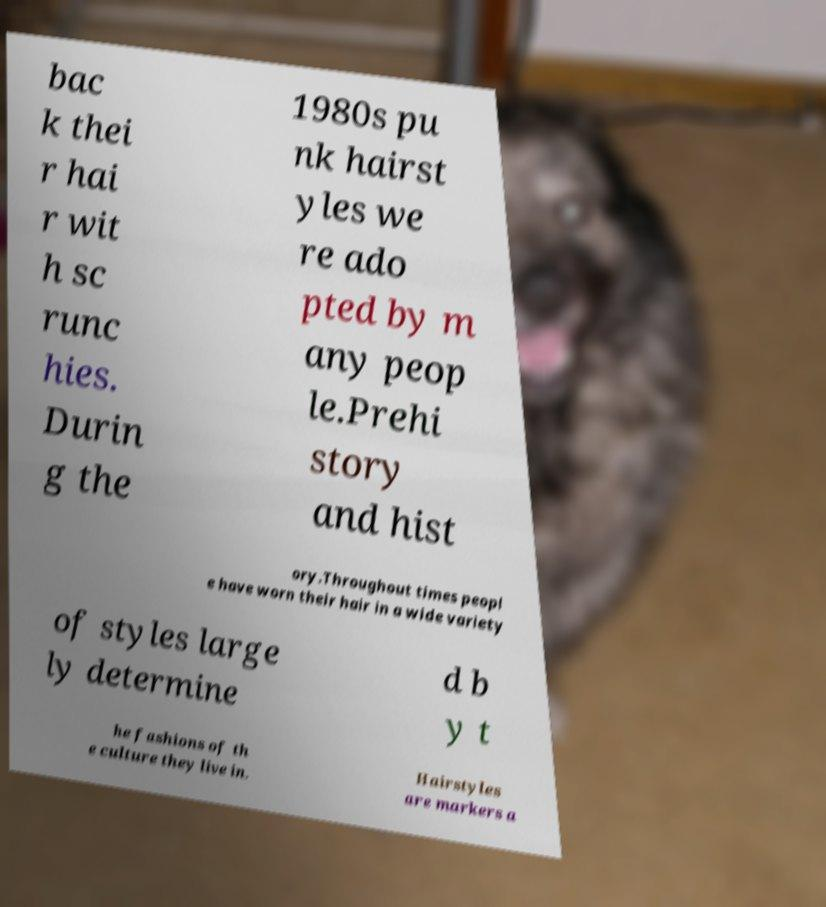I need the written content from this picture converted into text. Can you do that? bac k thei r hai r wit h sc runc hies. Durin g the 1980s pu nk hairst yles we re ado pted by m any peop le.Prehi story and hist ory.Throughout times peopl e have worn their hair in a wide variety of styles large ly determine d b y t he fashions of th e culture they live in. Hairstyles are markers a 